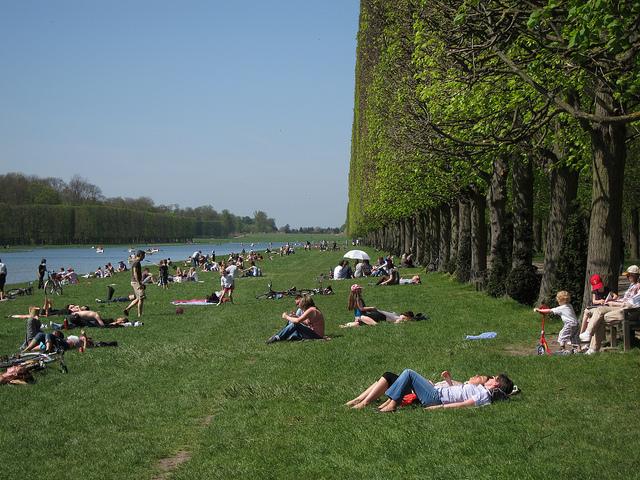Are there any clouds in the sky?
Write a very short answer. No. Are there any children in the picture?
Give a very brief answer. Yes. Are most people laying?
Quick response, please. Yes. What is in front of the dog?
Answer briefly. People. 